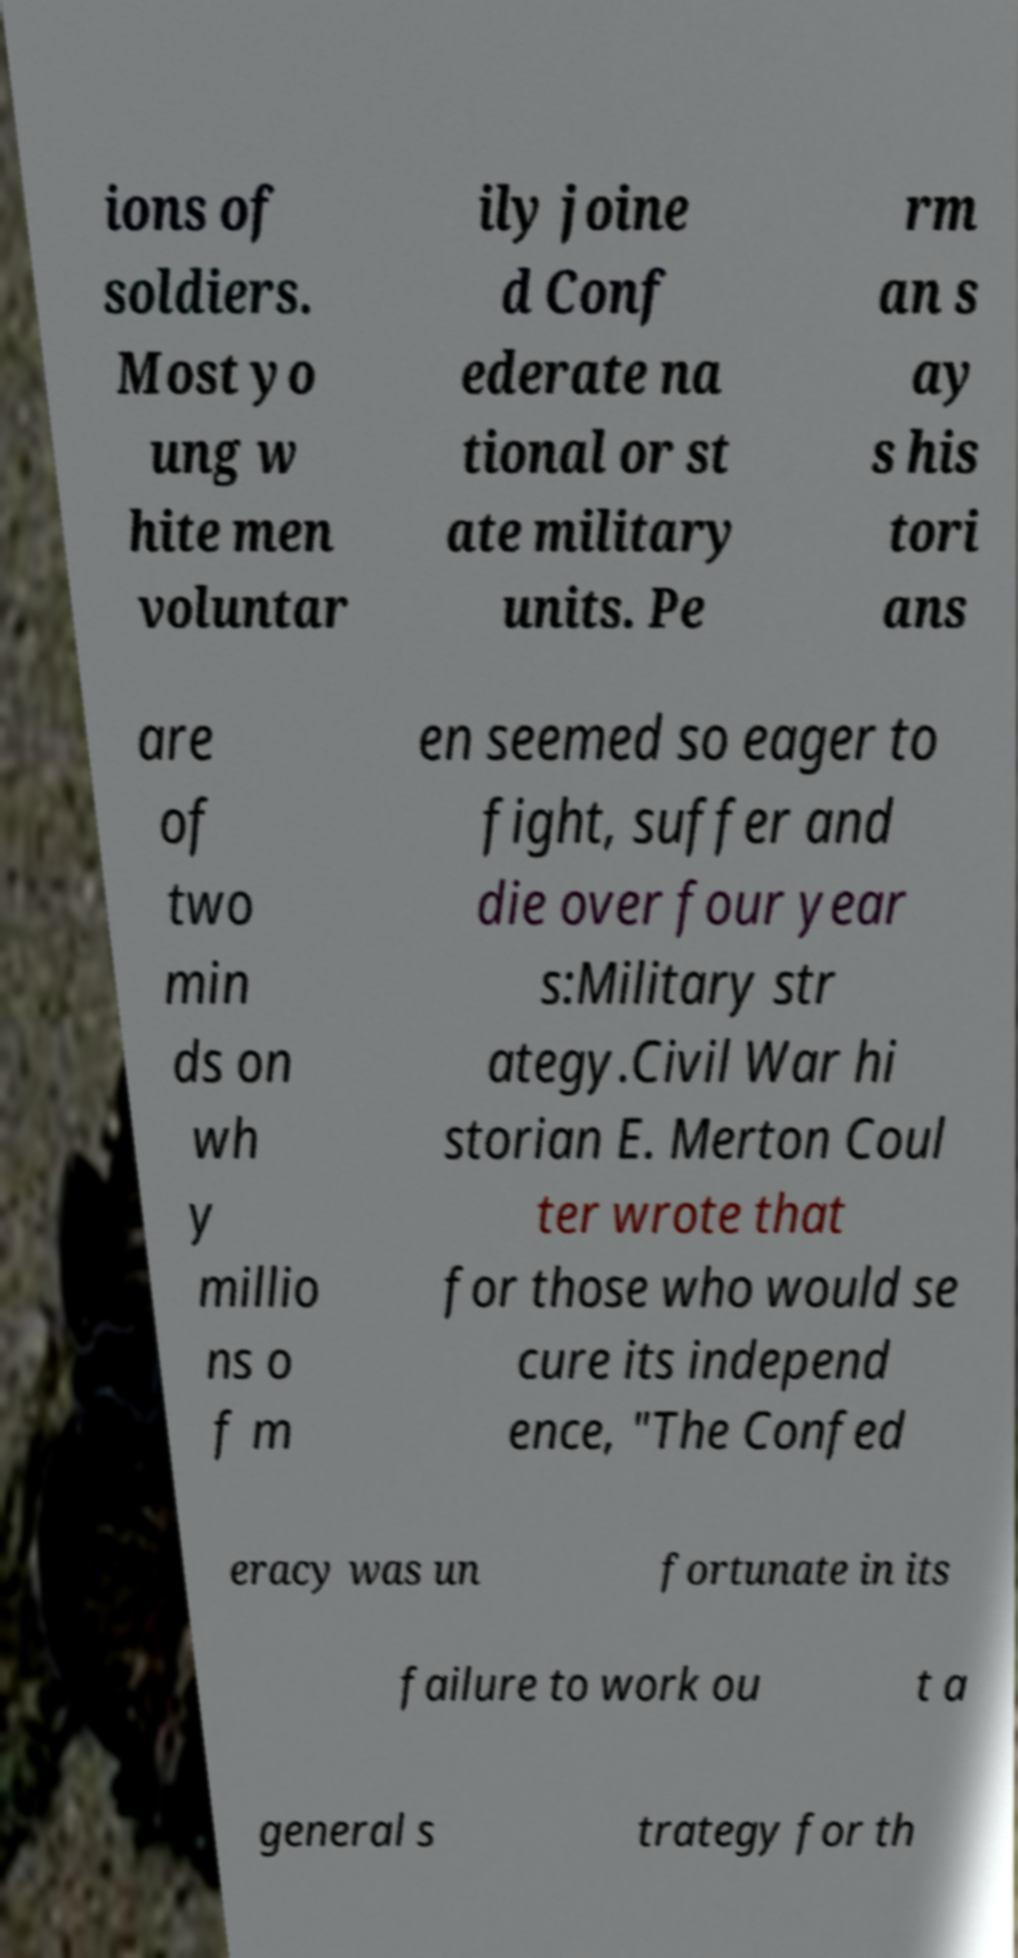Could you assist in decoding the text presented in this image and type it out clearly? ions of soldiers. Most yo ung w hite men voluntar ily joine d Conf ederate na tional or st ate military units. Pe rm an s ay s his tori ans are of two min ds on wh y millio ns o f m en seemed so eager to fight, suffer and die over four year s:Military str ategy.Civil War hi storian E. Merton Coul ter wrote that for those who would se cure its independ ence, "The Confed eracy was un fortunate in its failure to work ou t a general s trategy for th 